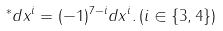Convert formula to latex. <formula><loc_0><loc_0><loc_500><loc_500>^ { * } d x ^ { i } = ( - 1 ) ^ { 7 - i } d x ^ { i } . \, ( i \in \{ 3 , 4 \} )</formula> 